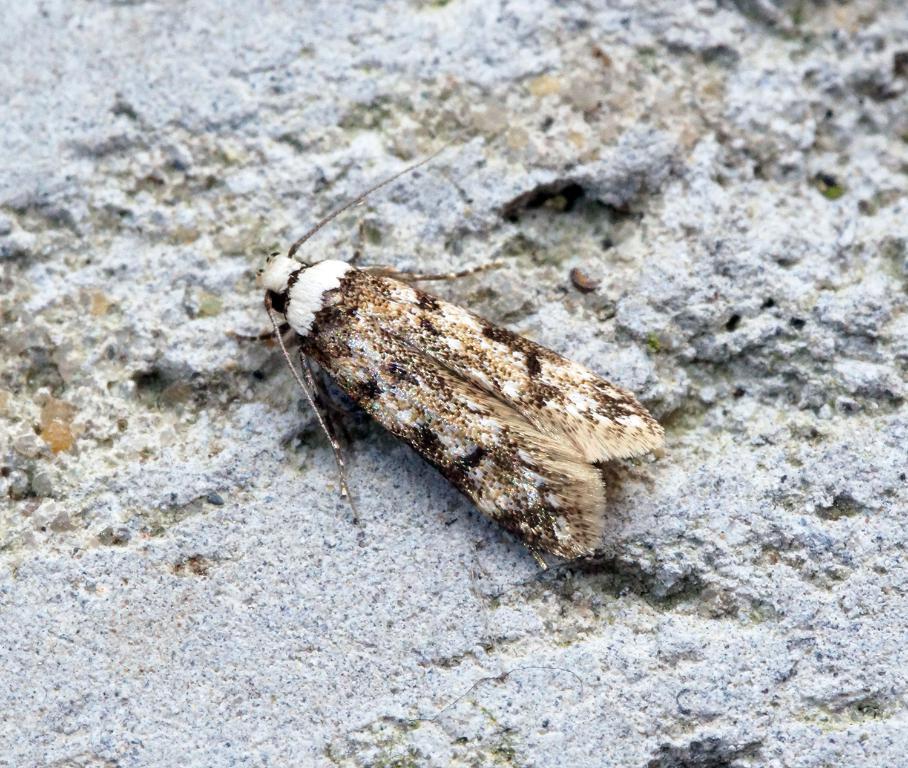Could you give a brief overview of what you see in this image? In the image in the center we can see one insect,which is in brown and white color. 